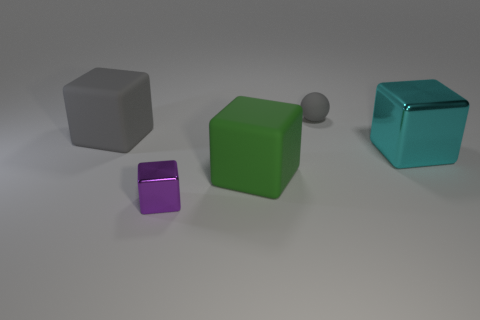Add 2 small gray rubber things. How many objects exist? 7 Subtract all big shiny blocks. How many blocks are left? 3 Subtract 1 blocks. How many blocks are left? 3 Subtract all purple blocks. How many blocks are left? 3 Subtract all gray cubes. Subtract all red cylinders. How many cubes are left? 3 Subtract all spheres. How many objects are left? 4 Subtract 0 brown cubes. How many objects are left? 5 Subtract all green matte things. Subtract all gray balls. How many objects are left? 3 Add 2 large cyan things. How many large cyan things are left? 3 Add 3 yellow metallic blocks. How many yellow metallic blocks exist? 3 